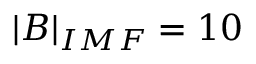<formula> <loc_0><loc_0><loc_500><loc_500>| B | _ { I M F } = 1 0</formula> 